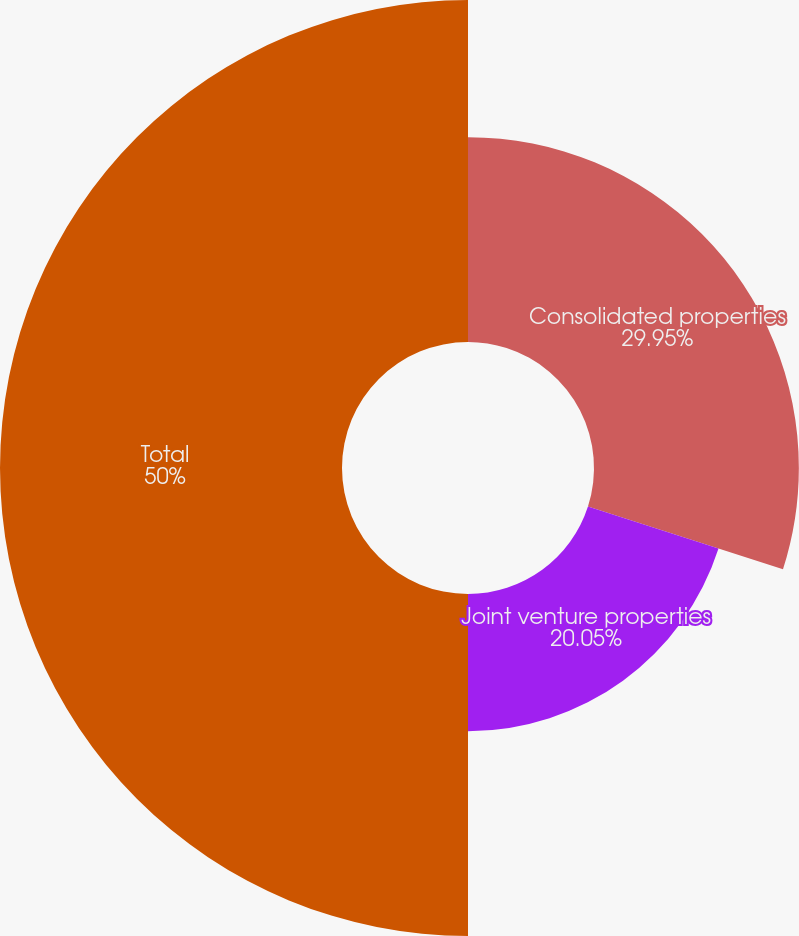Convert chart. <chart><loc_0><loc_0><loc_500><loc_500><pie_chart><fcel>Consolidated properties<fcel>Joint venture properties<fcel>Total<nl><fcel>29.95%<fcel>20.05%<fcel>50.0%<nl></chart> 